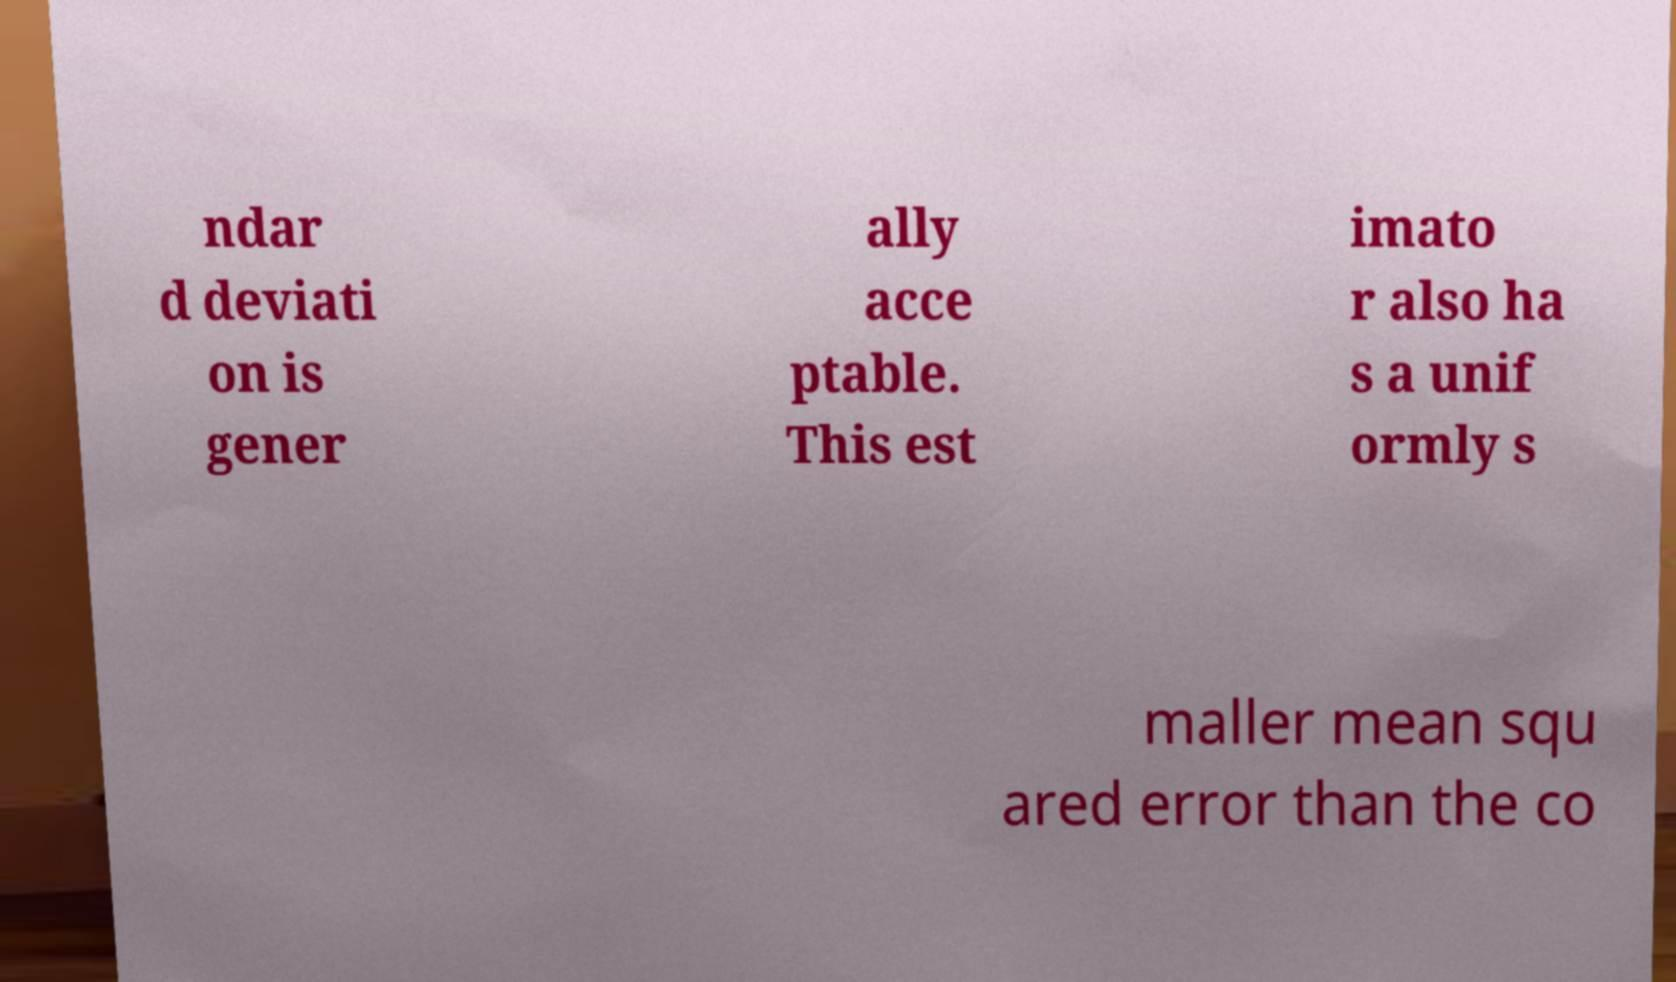Please identify and transcribe the text found in this image. ndar d deviati on is gener ally acce ptable. This est imato r also ha s a unif ormly s maller mean squ ared error than the co 